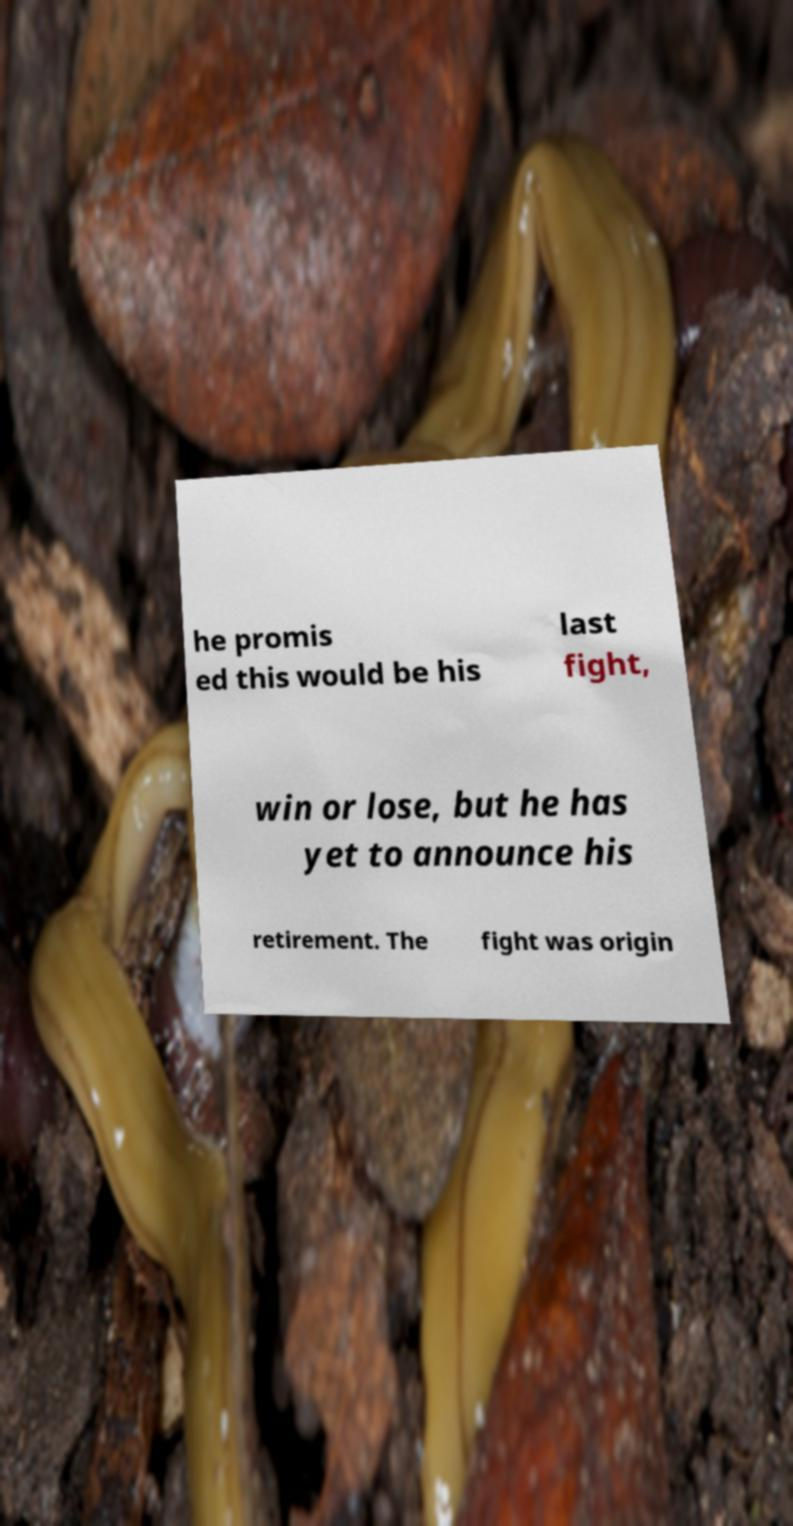Could you assist in decoding the text presented in this image and type it out clearly? he promis ed this would be his last fight, win or lose, but he has yet to announce his retirement. The fight was origin 